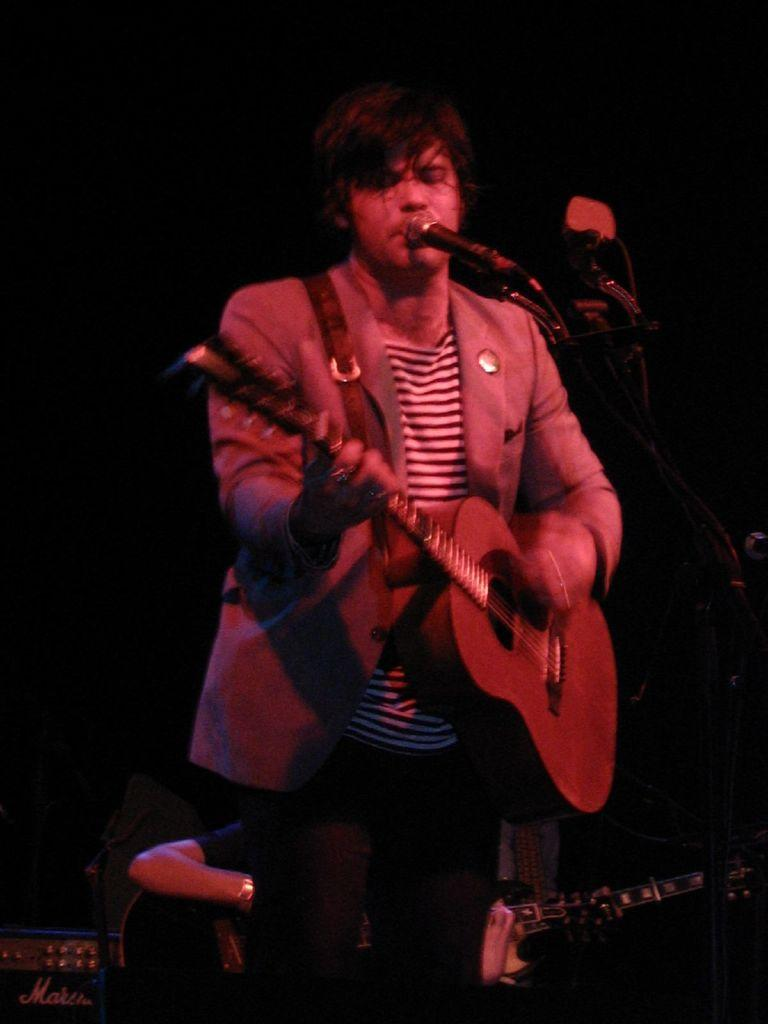What is the appearance of the man in the image? There is a man with grey hair in the image. What is the man doing in the image? The man is standing and playing a guitar. What object is in front of the man? There is a microphone in front of the man. Are there any other people in the image? Yes, there is another man playing a guitar behind the first man. What type of boot is the man's sister wearing in the image? There is no mention of a sister or a boot in the image; it features a man with grey hair playing a guitar with a microphone in front of him and another man playing a guitar behind him. 